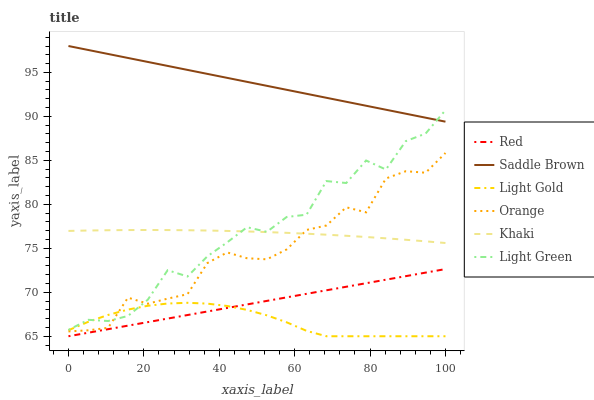Does Light Gold have the minimum area under the curve?
Answer yes or no. Yes. Does Saddle Brown have the maximum area under the curve?
Answer yes or no. Yes. Does Light Green have the minimum area under the curve?
Answer yes or no. No. Does Light Green have the maximum area under the curve?
Answer yes or no. No. Is Red the smoothest?
Answer yes or no. Yes. Is Light Green the roughest?
Answer yes or no. Yes. Is Orange the smoothest?
Answer yes or no. No. Is Orange the roughest?
Answer yes or no. No. Does Light Gold have the lowest value?
Answer yes or no. Yes. Does Light Green have the lowest value?
Answer yes or no. No. Does Saddle Brown have the highest value?
Answer yes or no. Yes. Does Light Green have the highest value?
Answer yes or no. No. Is Red less than Khaki?
Answer yes or no. Yes. Is Khaki greater than Light Gold?
Answer yes or no. Yes. Does Red intersect Light Gold?
Answer yes or no. Yes. Is Red less than Light Gold?
Answer yes or no. No. Is Red greater than Light Gold?
Answer yes or no. No. Does Red intersect Khaki?
Answer yes or no. No. 